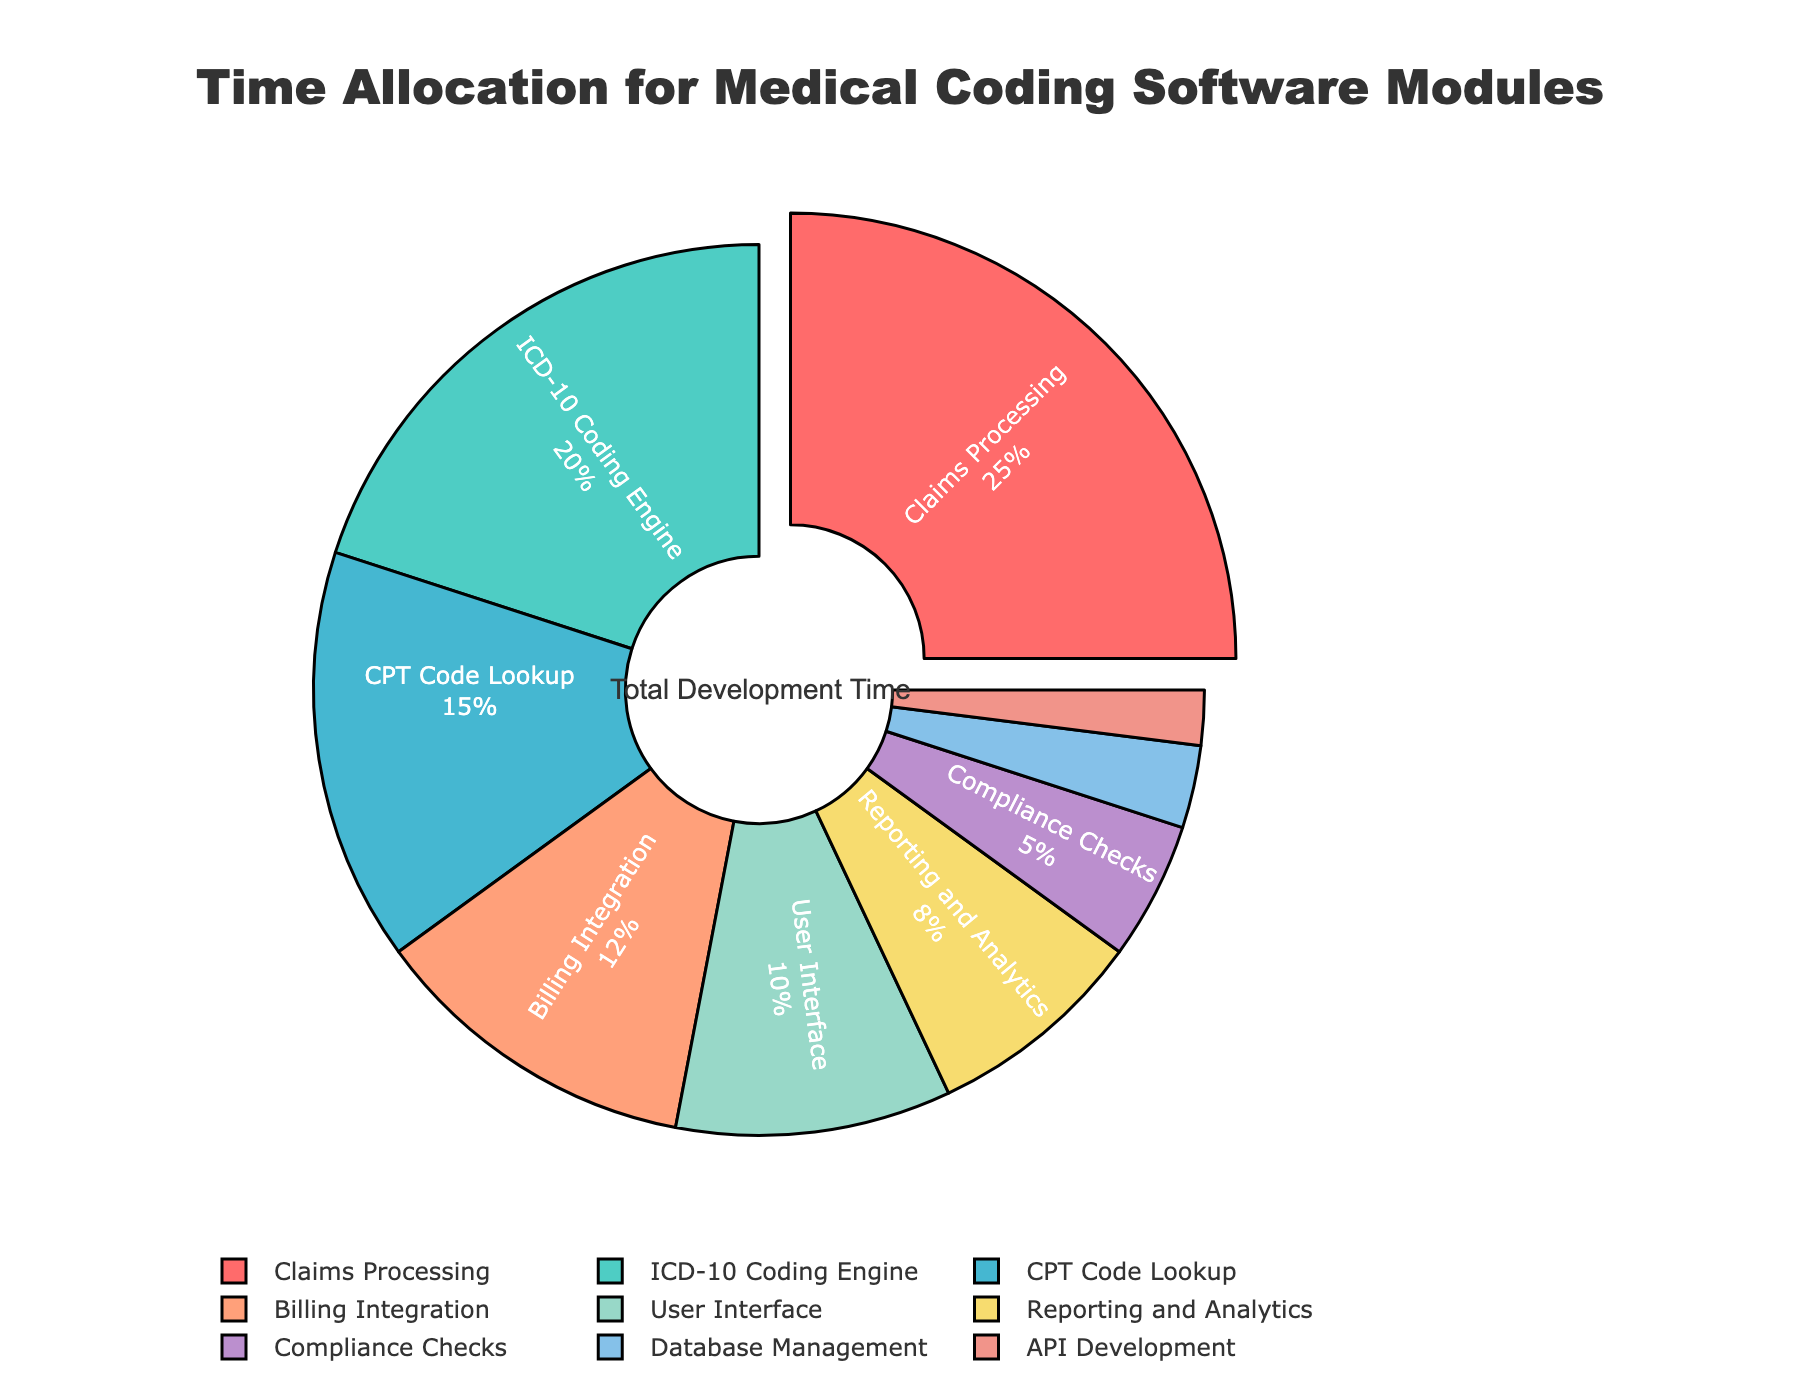Which module takes up the largest portion of development time? The largest portion of development time is indicated by the slice that is pulled out and is shown in red. This piece is labeled "Claims Processing" and occupies the biggest space in the pie chart.
Answer: Claims Processing How much development time is allocated to the ICD-10 Coding Engine and CPT Code Lookup combined? To find the combined development time for the ICD-10 Coding Engine and CPT Code Lookup modules, you need to sum their individual percentages: 20% (ICD-10 Coding Engine) + 15% (CPT Code Lookup) = 35%.
Answer: 35% Which module has double the percentage of Billing Integration? The Billing Integration module has 12%. A module with double this percentage would have 24%. The closest higher percentage shown in the pie chart is 25%, which corresponds to the Claims Processing module.
Answer: Claims Processing How much more time is allocated to Reporting and Analytics than to Database Management? Reporting and Analytics has 8% and Database Management has 3%. The difference between the two percentages is 8% - 3% = 5%.
Answer: 5% What is the total percentage of development time allocated to User Interface and API Development? The development time for User Interface is 10% and for API Development is 2%. Adding these two percentages gives 10% + 2% = 12%.
Answer: 12% Which module is represented by the purple color? The purple color slice represents the Compliance Checks module, as the colors are assigned in a specific order, and purple matches the 5% section in the chart.
Answer: Compliance Checks Is there any module that takes less than 5% of the total development time? If yes, which one(s)? By looking at the smallest percentages in the pie chart, we see that Database Management is 3% and API Development is 2%, both of which are less than 5%.
Answer: Database Management, API Development Which two modules combined would almost equal the time spent on Claims Processing? The Claims Processing module takes 25%. The ICD-10 Coding Engine takes 20%, and the CPT Code Lookup takes 15%. The combination closest to 25% is Reporting and Analytics (8%) + Billing Integration (12%) which sums up to 20%. Adding the module with 5% (Compliance Checks) sums up to 20% + 5% = 25%, matching the time spent on Claims Processing.
Answer: Reporting and Analytics + Billing Integration + Compliance Checks 